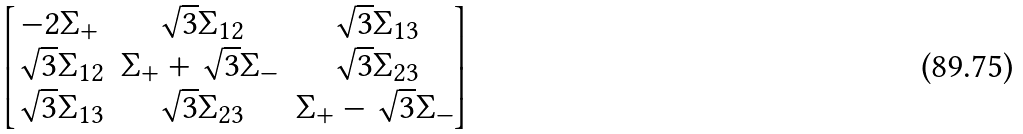<formula> <loc_0><loc_0><loc_500><loc_500>\begin{bmatrix} - 2 \Sigma _ { + } & \sqrt { 3 } \Sigma _ { 1 2 } & \sqrt { 3 } \Sigma _ { 1 3 } \\ \sqrt { 3 } \Sigma _ { 1 2 } & \Sigma _ { + } + \sqrt { 3 } \Sigma _ { - } & \sqrt { 3 } \Sigma _ { 2 3 } \\ \sqrt { 3 } \Sigma _ { 1 3 } & \sqrt { 3 } \Sigma _ { 2 3 } & \Sigma _ { + } - \sqrt { 3 } \Sigma _ { - } \end{bmatrix}</formula> 